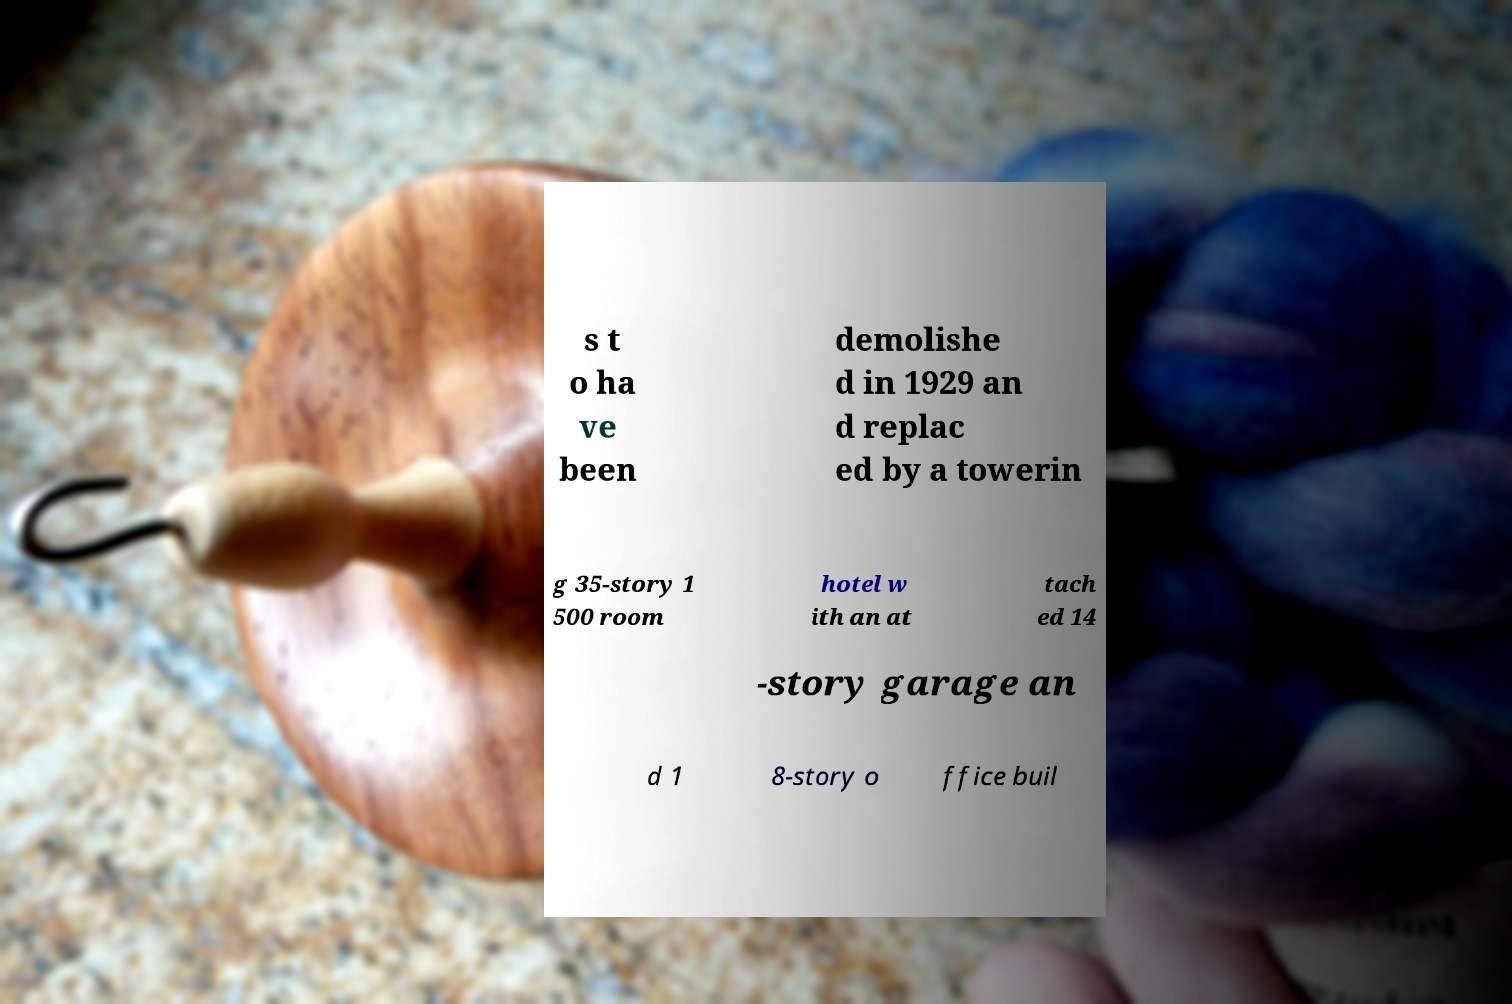Can you accurately transcribe the text from the provided image for me? s t o ha ve been demolishe d in 1929 an d replac ed by a towerin g 35-story 1 500 room hotel w ith an at tach ed 14 -story garage an d 1 8-story o ffice buil 